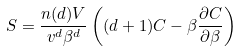Convert formula to latex. <formula><loc_0><loc_0><loc_500><loc_500>S = \frac { n ( d ) V } { v ^ { d } \beta ^ { d } } \left ( ( d + 1 ) C - \beta \frac { \partial C } { \partial \beta } \right )</formula> 